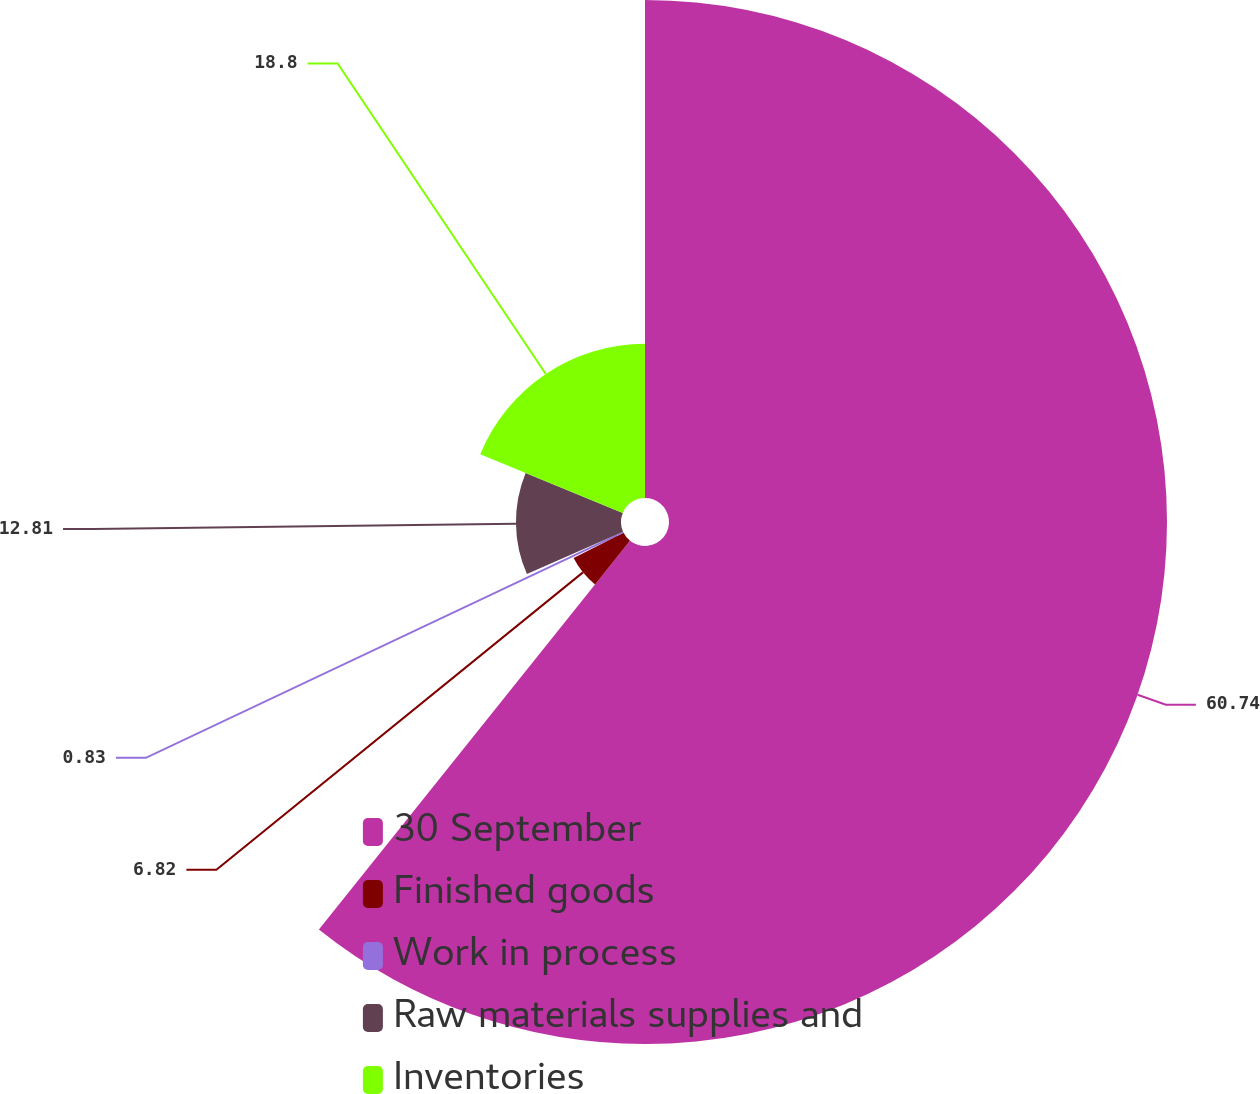<chart> <loc_0><loc_0><loc_500><loc_500><pie_chart><fcel>30 September<fcel>Finished goods<fcel>Work in process<fcel>Raw materials supplies and<fcel>Inventories<nl><fcel>60.74%<fcel>6.82%<fcel>0.83%<fcel>12.81%<fcel>18.8%<nl></chart> 